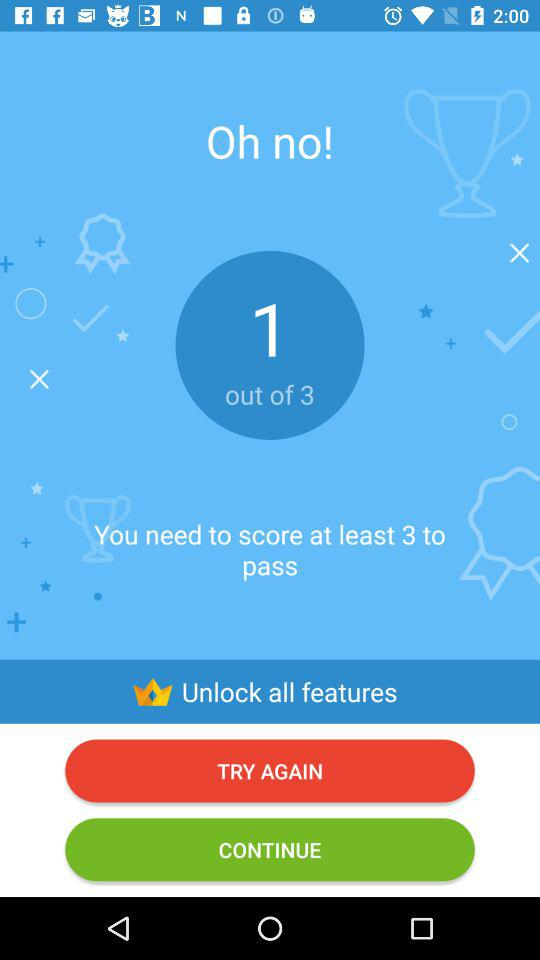What scores did I get out of three? You scored one out of three. 